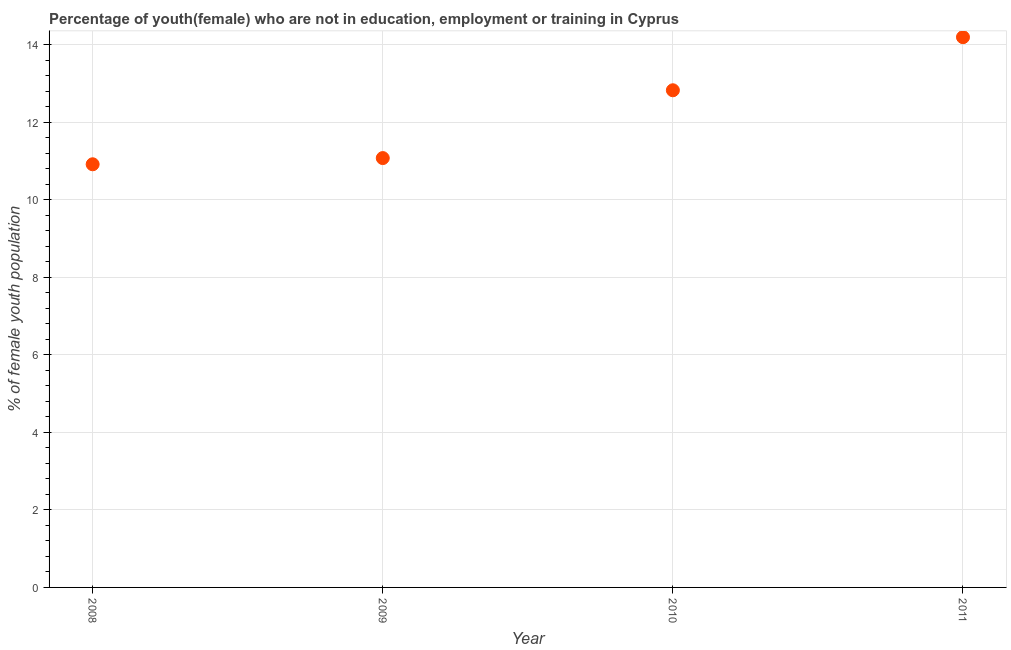What is the unemployed female youth population in 2009?
Your response must be concise. 11.08. Across all years, what is the maximum unemployed female youth population?
Your answer should be very brief. 14.2. Across all years, what is the minimum unemployed female youth population?
Make the answer very short. 10.92. In which year was the unemployed female youth population maximum?
Your response must be concise. 2011. What is the sum of the unemployed female youth population?
Your response must be concise. 49.03. What is the difference between the unemployed female youth population in 2008 and 2011?
Your answer should be compact. -3.28. What is the average unemployed female youth population per year?
Provide a short and direct response. 12.26. What is the median unemployed female youth population?
Ensure brevity in your answer.  11.95. In how many years, is the unemployed female youth population greater than 12.4 %?
Your answer should be very brief. 2. What is the ratio of the unemployed female youth population in 2009 to that in 2010?
Keep it short and to the point. 0.86. What is the difference between the highest and the second highest unemployed female youth population?
Your answer should be very brief. 1.37. What is the difference between the highest and the lowest unemployed female youth population?
Offer a terse response. 3.28. How many years are there in the graph?
Provide a succinct answer. 4. Are the values on the major ticks of Y-axis written in scientific E-notation?
Provide a succinct answer. No. Does the graph contain any zero values?
Your answer should be very brief. No. What is the title of the graph?
Offer a terse response. Percentage of youth(female) who are not in education, employment or training in Cyprus. What is the label or title of the Y-axis?
Keep it short and to the point. % of female youth population. What is the % of female youth population in 2008?
Your answer should be compact. 10.92. What is the % of female youth population in 2009?
Give a very brief answer. 11.08. What is the % of female youth population in 2010?
Provide a short and direct response. 12.83. What is the % of female youth population in 2011?
Your answer should be very brief. 14.2. What is the difference between the % of female youth population in 2008 and 2009?
Offer a very short reply. -0.16. What is the difference between the % of female youth population in 2008 and 2010?
Offer a terse response. -1.91. What is the difference between the % of female youth population in 2008 and 2011?
Make the answer very short. -3.28. What is the difference between the % of female youth population in 2009 and 2010?
Offer a terse response. -1.75. What is the difference between the % of female youth population in 2009 and 2011?
Keep it short and to the point. -3.12. What is the difference between the % of female youth population in 2010 and 2011?
Ensure brevity in your answer.  -1.37. What is the ratio of the % of female youth population in 2008 to that in 2009?
Your response must be concise. 0.99. What is the ratio of the % of female youth population in 2008 to that in 2010?
Ensure brevity in your answer.  0.85. What is the ratio of the % of female youth population in 2008 to that in 2011?
Give a very brief answer. 0.77. What is the ratio of the % of female youth population in 2009 to that in 2010?
Give a very brief answer. 0.86. What is the ratio of the % of female youth population in 2009 to that in 2011?
Your answer should be compact. 0.78. What is the ratio of the % of female youth population in 2010 to that in 2011?
Your response must be concise. 0.9. 